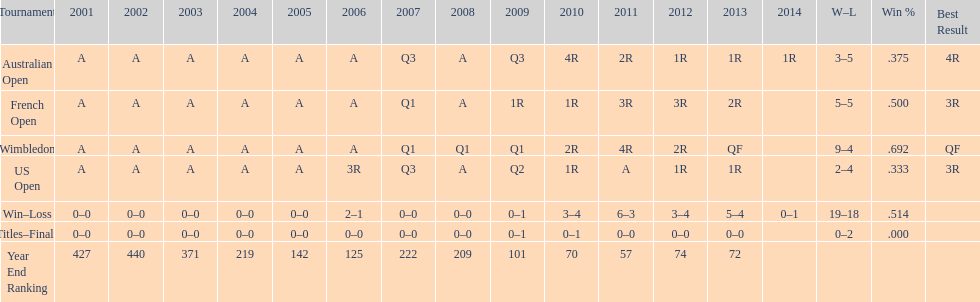In what year was the best year end ranking achieved? 2011. 